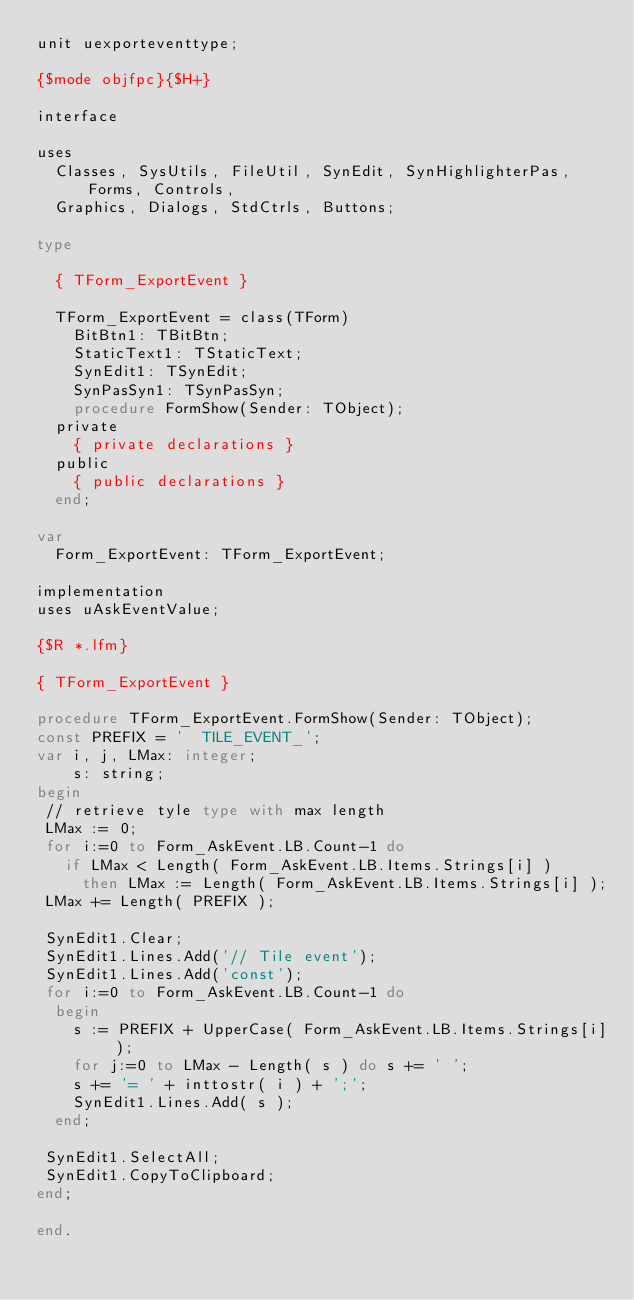Convert code to text. <code><loc_0><loc_0><loc_500><loc_500><_Pascal_>unit uexporteventtype;

{$mode objfpc}{$H+}

interface

uses
  Classes, SysUtils, FileUtil, SynEdit, SynHighlighterPas, Forms, Controls,
  Graphics, Dialogs, StdCtrls, Buttons;

type

  { TForm_ExportEvent }

  TForm_ExportEvent = class(TForm)
    BitBtn1: TBitBtn;
    StaticText1: TStaticText;
    SynEdit1: TSynEdit;
    SynPasSyn1: TSynPasSyn;
    procedure FormShow(Sender: TObject);
  private
    { private declarations }
  public
    { public declarations }
  end;

var
  Form_ExportEvent: TForm_ExportEvent;

implementation
uses uAskEventValue;

{$R *.lfm}

{ TForm_ExportEvent }

procedure TForm_ExportEvent.FormShow(Sender: TObject);
const PREFIX = '  TILE_EVENT_';
var i, j, LMax: integer;
    s: string;
begin
 // retrieve tyle type with max length
 LMax := 0;
 for i:=0 to Form_AskEvent.LB.Count-1 do
   if LMax < Length( Form_AskEvent.LB.Items.Strings[i] )
     then LMax := Length( Form_AskEvent.LB.Items.Strings[i] );
 LMax += Length( PREFIX );

 SynEdit1.Clear;
 SynEdit1.Lines.Add('// Tile event');
 SynEdit1.Lines.Add('const');
 for i:=0 to Form_AskEvent.LB.Count-1 do
  begin
    s := PREFIX + UpperCase( Form_AskEvent.LB.Items.Strings[i] );
    for j:=0 to LMax - Length( s ) do s += ' ';
    s += '= ' + inttostr( i ) + ';';
    SynEdit1.Lines.Add( s );
  end;

 SynEdit1.SelectAll;
 SynEdit1.CopyToClipboard;
end;

end.

</code> 